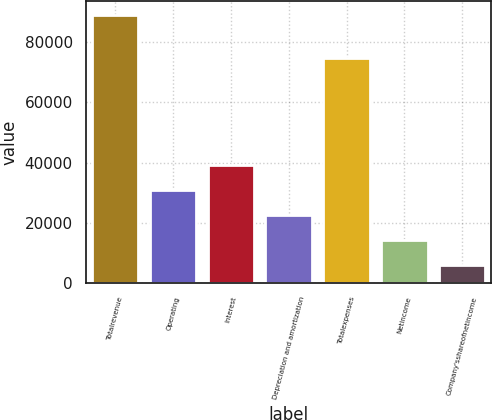<chart> <loc_0><loc_0><loc_500><loc_500><bar_chart><fcel>Totalrevenue<fcel>Operating<fcel>Interest<fcel>Depreciation and amortization<fcel>Totalexpenses<fcel>Netincome<fcel>Company'sshareofnetincome<nl><fcel>89027<fcel>30919.3<fcel>39220.4<fcel>22618.2<fcel>74804<fcel>14317.1<fcel>6016<nl></chart> 